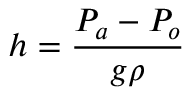<formula> <loc_0><loc_0><loc_500><loc_500>h = { \frac { P _ { a } - P _ { o } } { g \rho } }</formula> 